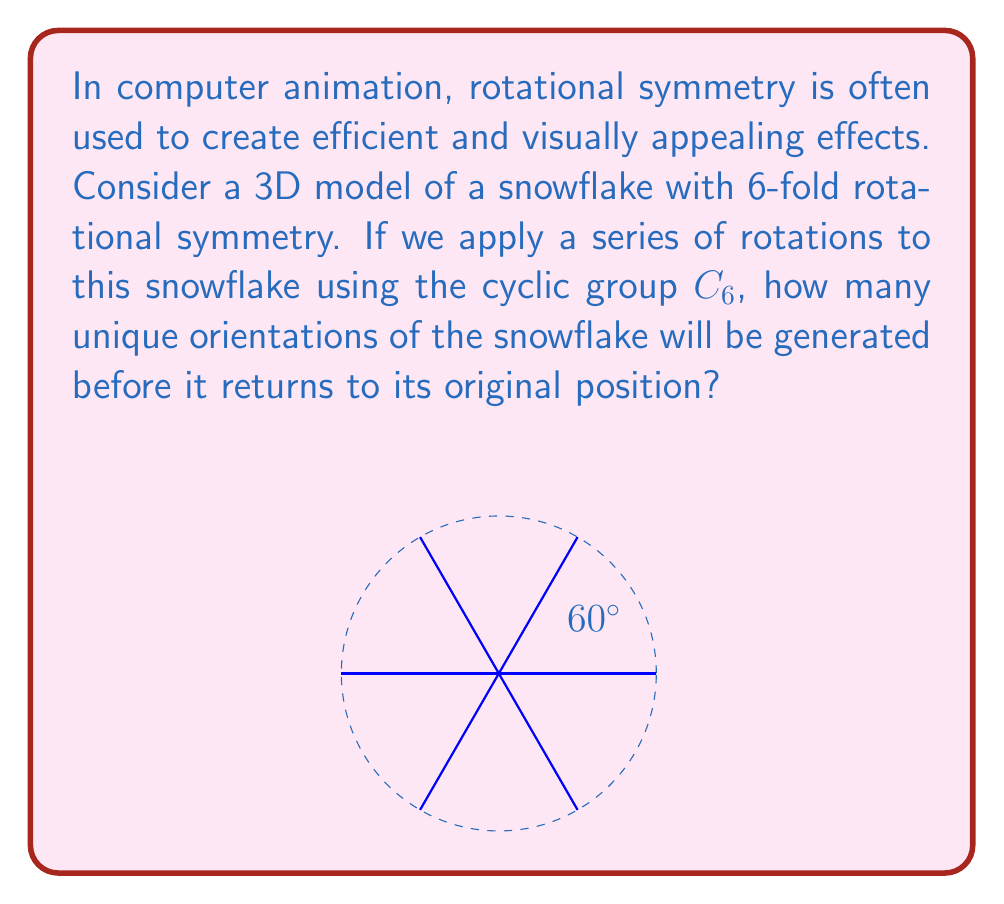Can you solve this math problem? Let's approach this step-by-step:

1) The cyclic group $C_6$ represents rotations by multiples of $\frac{2\pi}{6} = \frac{\pi}{3} = 60°$.

2) The elements of $C_6$ can be represented as:
   $$C_6 = \{e, r, r^2, r^3, r^4, r^5\}$$
   where $e$ is the identity (no rotation) and $r$ represents a 60° rotation.

3) Each application of $r$ will produce a new orientation until we complete a full 360° rotation:
   - $e$: 0° (original position)
   - $r$: 60°
   - $r^2$: 120°
   - $r^3$: 180°
   - $r^4$: 240°
   - $r^5$: 300°
   - $r^6 = e$: 360° (back to original position)

4) The snowflake has 6-fold rotational symmetry, which means it looks the same after every 60° rotation.

5) Therefore, each element of $C_6$ will produce a unique orientation of the snowflake.

6) The number of unique orientations is equal to the order of the cyclic group $C_6$, which is 6.

This demonstrates how cyclic groups can be efficiently used in computer graphics to generate symmetric rotations, reducing the amount of data needed to represent and animate complex symmetrical objects.
Answer: 6 unique orientations 